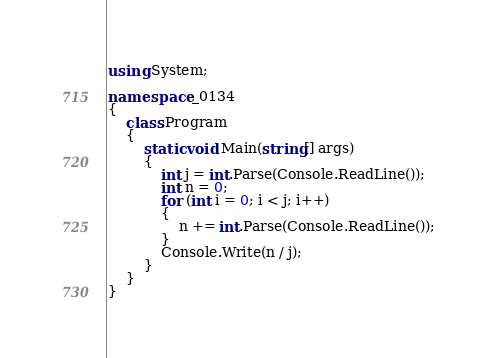<code> <loc_0><loc_0><loc_500><loc_500><_C#_>using System;

namespace _0134
{
    class Program
    {
        static void Main(string[] args)
        {
            int j = int.Parse(Console.ReadLine());
            int n = 0;
            for (int i = 0; i < j; i++)
            {
                n += int.Parse(Console.ReadLine());
            }
            Console.Write(n / j);
        }
    }
}</code> 